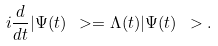Convert formula to latex. <formula><loc_0><loc_0><loc_500><loc_500>i \frac { d } { d t } | \Psi ( t ) \ > = \Lambda ( t ) | \Psi ( t ) \ > .</formula> 